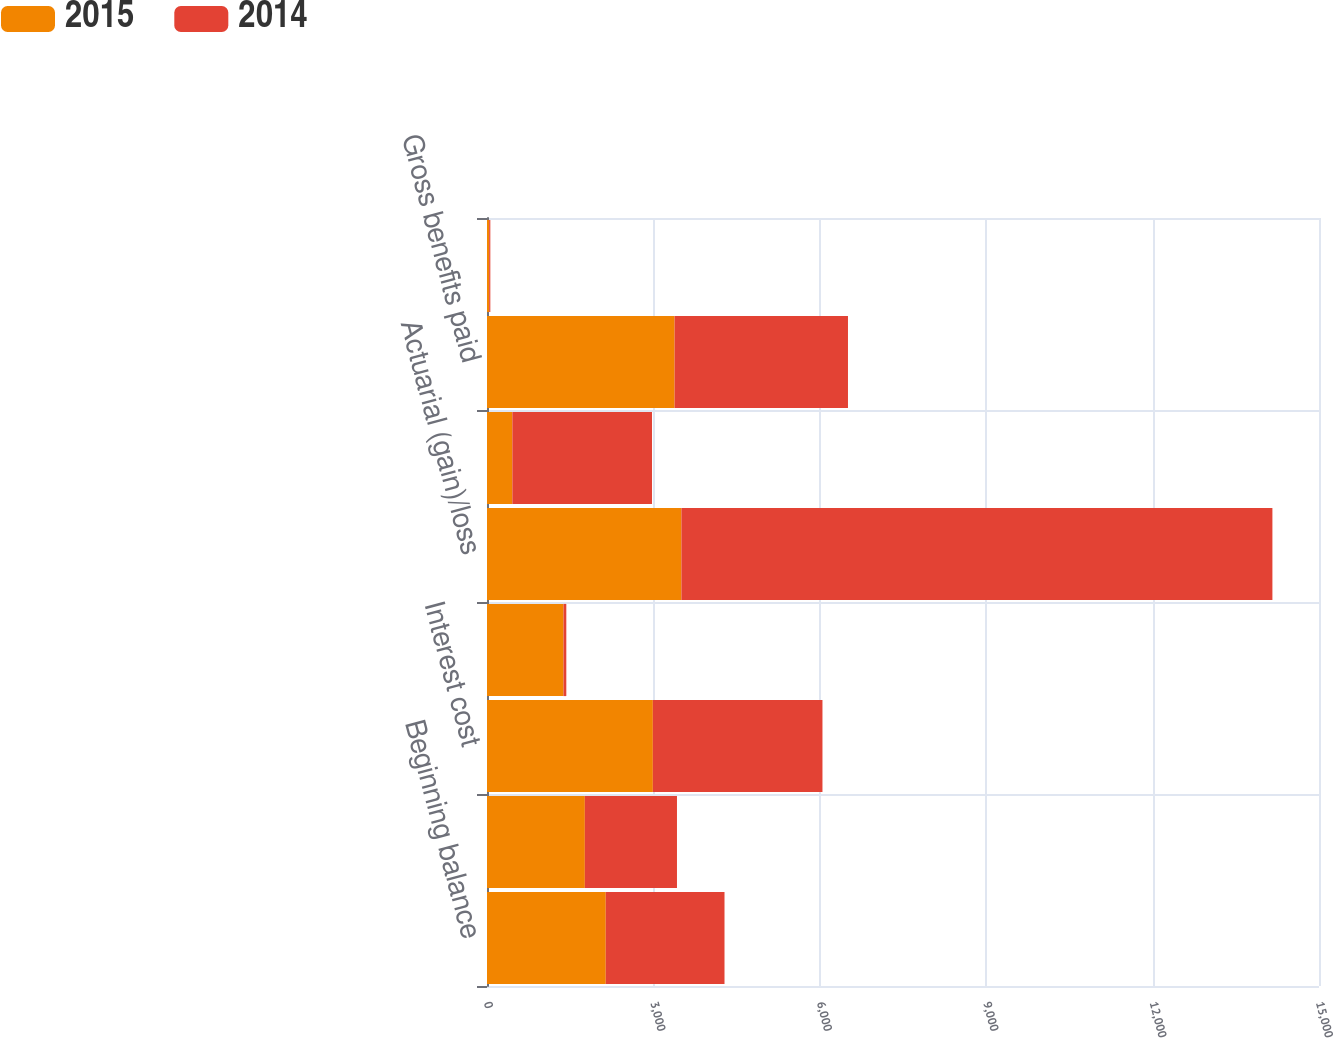<chart> <loc_0><loc_0><loc_500><loc_500><stacked_bar_chart><ecel><fcel>Beginning balance<fcel>Service cost<fcel>Interest cost<fcel>Amendments<fcel>Actuarial (gain)/loss<fcel>Settlement/curtailment/other<fcel>Gross benefits paid<fcel>Exchange rate adjustment<nl><fcel>2015<fcel>2141<fcel>1764<fcel>2990<fcel>1379<fcel>3505<fcel>457<fcel>3382<fcel>39<nl><fcel>2014<fcel>2141<fcel>1661<fcel>3058<fcel>51<fcel>10655<fcel>2518<fcel>3126<fcel>21<nl></chart> 